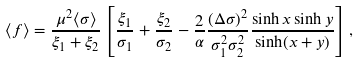<formula> <loc_0><loc_0><loc_500><loc_500>\langle f \rangle = \frac { \mu ^ { 2 } \langle \sigma \rangle } { \xi _ { 1 } + \xi _ { 2 } } \left [ \frac { \xi _ { 1 } } { \sigma _ { 1 } } + \frac { \xi _ { 2 } } { \sigma _ { 2 } } - \frac { 2 } { \alpha } \frac { ( \Delta \sigma ) ^ { 2 } } { \sigma _ { 1 } ^ { 2 } \sigma _ { 2 } ^ { 2 } } \frac { \sinh x \sinh y } { \sinh ( x + y ) } \right ] ,</formula> 